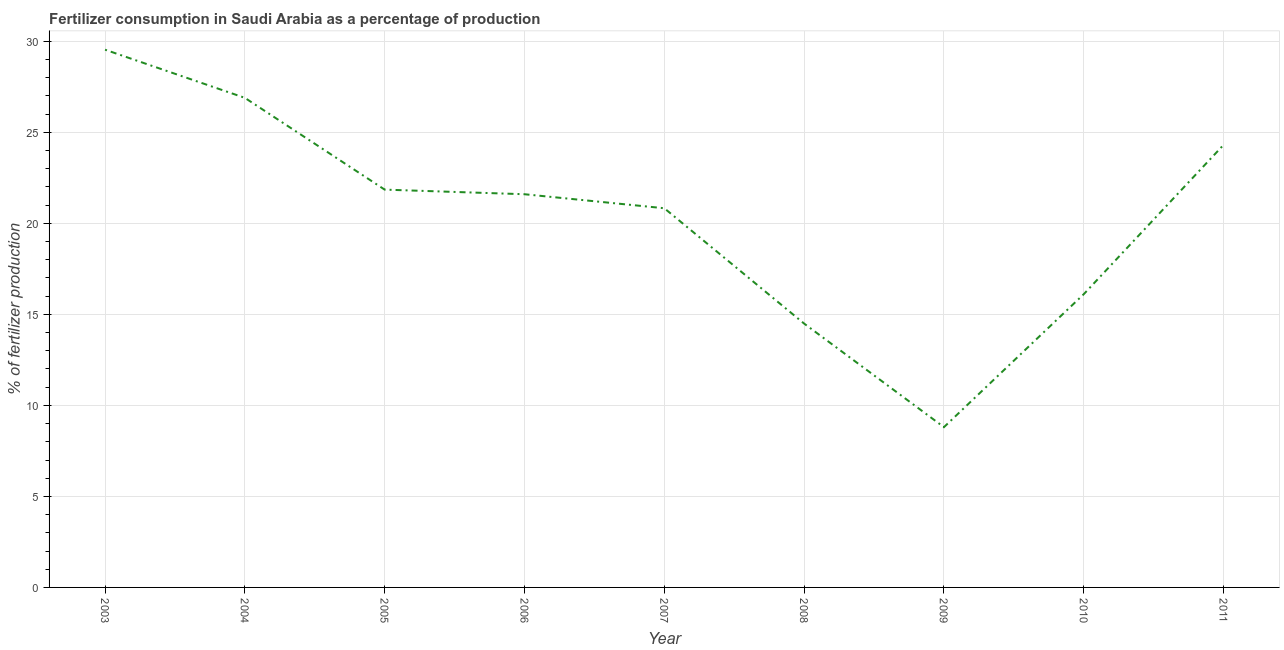What is the amount of fertilizer consumption in 2005?
Make the answer very short. 21.85. Across all years, what is the maximum amount of fertilizer consumption?
Your answer should be compact. 29.54. Across all years, what is the minimum amount of fertilizer consumption?
Make the answer very short. 8.81. In which year was the amount of fertilizer consumption maximum?
Your answer should be very brief. 2003. What is the sum of the amount of fertilizer consumption?
Your answer should be very brief. 184.44. What is the difference between the amount of fertilizer consumption in 2007 and 2008?
Your response must be concise. 6.34. What is the average amount of fertilizer consumption per year?
Ensure brevity in your answer.  20.49. What is the median amount of fertilizer consumption?
Make the answer very short. 21.6. What is the ratio of the amount of fertilizer consumption in 2009 to that in 2010?
Provide a succinct answer. 0.55. Is the amount of fertilizer consumption in 2004 less than that in 2011?
Offer a terse response. No. What is the difference between the highest and the second highest amount of fertilizer consumption?
Your response must be concise. 2.65. What is the difference between the highest and the lowest amount of fertilizer consumption?
Your answer should be compact. 20.74. In how many years, is the amount of fertilizer consumption greater than the average amount of fertilizer consumption taken over all years?
Give a very brief answer. 6. Does the amount of fertilizer consumption monotonically increase over the years?
Ensure brevity in your answer.  No. How many lines are there?
Make the answer very short. 1. What is the difference between two consecutive major ticks on the Y-axis?
Provide a succinct answer. 5. Does the graph contain any zero values?
Offer a very short reply. No. What is the title of the graph?
Your answer should be compact. Fertilizer consumption in Saudi Arabia as a percentage of production. What is the label or title of the X-axis?
Provide a succinct answer. Year. What is the label or title of the Y-axis?
Provide a short and direct response. % of fertilizer production. What is the % of fertilizer production in 2003?
Offer a terse response. 29.54. What is the % of fertilizer production in 2004?
Your response must be concise. 26.9. What is the % of fertilizer production of 2005?
Offer a terse response. 21.85. What is the % of fertilizer production of 2006?
Provide a succinct answer. 21.6. What is the % of fertilizer production in 2007?
Ensure brevity in your answer.  20.83. What is the % of fertilizer production in 2008?
Ensure brevity in your answer.  14.49. What is the % of fertilizer production of 2009?
Your answer should be compact. 8.81. What is the % of fertilizer production in 2010?
Your answer should be compact. 16.11. What is the % of fertilizer production in 2011?
Your answer should be compact. 24.31. What is the difference between the % of fertilizer production in 2003 and 2004?
Provide a succinct answer. 2.65. What is the difference between the % of fertilizer production in 2003 and 2005?
Offer a terse response. 7.69. What is the difference between the % of fertilizer production in 2003 and 2006?
Ensure brevity in your answer.  7.94. What is the difference between the % of fertilizer production in 2003 and 2007?
Your answer should be compact. 8.71. What is the difference between the % of fertilizer production in 2003 and 2008?
Provide a succinct answer. 15.05. What is the difference between the % of fertilizer production in 2003 and 2009?
Offer a very short reply. 20.74. What is the difference between the % of fertilizer production in 2003 and 2010?
Keep it short and to the point. 13.43. What is the difference between the % of fertilizer production in 2003 and 2011?
Your response must be concise. 5.23. What is the difference between the % of fertilizer production in 2004 and 2005?
Your response must be concise. 5.04. What is the difference between the % of fertilizer production in 2004 and 2006?
Provide a short and direct response. 5.29. What is the difference between the % of fertilizer production in 2004 and 2007?
Offer a terse response. 6.06. What is the difference between the % of fertilizer production in 2004 and 2008?
Your answer should be very brief. 12.4. What is the difference between the % of fertilizer production in 2004 and 2009?
Ensure brevity in your answer.  18.09. What is the difference between the % of fertilizer production in 2004 and 2010?
Offer a terse response. 10.79. What is the difference between the % of fertilizer production in 2004 and 2011?
Offer a very short reply. 2.58. What is the difference between the % of fertilizer production in 2005 and 2006?
Provide a succinct answer. 0.25. What is the difference between the % of fertilizer production in 2005 and 2007?
Your answer should be very brief. 1.02. What is the difference between the % of fertilizer production in 2005 and 2008?
Make the answer very short. 7.36. What is the difference between the % of fertilizer production in 2005 and 2009?
Your answer should be very brief. 13.05. What is the difference between the % of fertilizer production in 2005 and 2010?
Ensure brevity in your answer.  5.74. What is the difference between the % of fertilizer production in 2005 and 2011?
Provide a short and direct response. -2.46. What is the difference between the % of fertilizer production in 2006 and 2007?
Your answer should be very brief. 0.77. What is the difference between the % of fertilizer production in 2006 and 2008?
Provide a succinct answer. 7.11. What is the difference between the % of fertilizer production in 2006 and 2009?
Ensure brevity in your answer.  12.8. What is the difference between the % of fertilizer production in 2006 and 2010?
Your response must be concise. 5.49. What is the difference between the % of fertilizer production in 2006 and 2011?
Offer a very short reply. -2.71. What is the difference between the % of fertilizer production in 2007 and 2008?
Give a very brief answer. 6.34. What is the difference between the % of fertilizer production in 2007 and 2009?
Offer a very short reply. 12.03. What is the difference between the % of fertilizer production in 2007 and 2010?
Ensure brevity in your answer.  4.72. What is the difference between the % of fertilizer production in 2007 and 2011?
Your answer should be very brief. -3.48. What is the difference between the % of fertilizer production in 2008 and 2009?
Give a very brief answer. 5.69. What is the difference between the % of fertilizer production in 2008 and 2010?
Make the answer very short. -1.62. What is the difference between the % of fertilizer production in 2008 and 2011?
Keep it short and to the point. -9.82. What is the difference between the % of fertilizer production in 2009 and 2010?
Offer a terse response. -7.3. What is the difference between the % of fertilizer production in 2009 and 2011?
Make the answer very short. -15.51. What is the difference between the % of fertilizer production in 2010 and 2011?
Your answer should be very brief. -8.2. What is the ratio of the % of fertilizer production in 2003 to that in 2004?
Keep it short and to the point. 1.1. What is the ratio of the % of fertilizer production in 2003 to that in 2005?
Provide a succinct answer. 1.35. What is the ratio of the % of fertilizer production in 2003 to that in 2006?
Make the answer very short. 1.37. What is the ratio of the % of fertilizer production in 2003 to that in 2007?
Provide a succinct answer. 1.42. What is the ratio of the % of fertilizer production in 2003 to that in 2008?
Your response must be concise. 2.04. What is the ratio of the % of fertilizer production in 2003 to that in 2009?
Offer a very short reply. 3.35. What is the ratio of the % of fertilizer production in 2003 to that in 2010?
Your answer should be compact. 1.83. What is the ratio of the % of fertilizer production in 2003 to that in 2011?
Make the answer very short. 1.22. What is the ratio of the % of fertilizer production in 2004 to that in 2005?
Your response must be concise. 1.23. What is the ratio of the % of fertilizer production in 2004 to that in 2006?
Ensure brevity in your answer.  1.25. What is the ratio of the % of fertilizer production in 2004 to that in 2007?
Give a very brief answer. 1.29. What is the ratio of the % of fertilizer production in 2004 to that in 2008?
Provide a succinct answer. 1.86. What is the ratio of the % of fertilizer production in 2004 to that in 2009?
Offer a terse response. 3.06. What is the ratio of the % of fertilizer production in 2004 to that in 2010?
Your response must be concise. 1.67. What is the ratio of the % of fertilizer production in 2004 to that in 2011?
Offer a very short reply. 1.11. What is the ratio of the % of fertilizer production in 2005 to that in 2006?
Give a very brief answer. 1.01. What is the ratio of the % of fertilizer production in 2005 to that in 2007?
Give a very brief answer. 1.05. What is the ratio of the % of fertilizer production in 2005 to that in 2008?
Provide a short and direct response. 1.51. What is the ratio of the % of fertilizer production in 2005 to that in 2009?
Offer a terse response. 2.48. What is the ratio of the % of fertilizer production in 2005 to that in 2010?
Provide a short and direct response. 1.36. What is the ratio of the % of fertilizer production in 2005 to that in 2011?
Offer a terse response. 0.9. What is the ratio of the % of fertilizer production in 2006 to that in 2007?
Give a very brief answer. 1.04. What is the ratio of the % of fertilizer production in 2006 to that in 2008?
Offer a very short reply. 1.49. What is the ratio of the % of fertilizer production in 2006 to that in 2009?
Make the answer very short. 2.45. What is the ratio of the % of fertilizer production in 2006 to that in 2010?
Ensure brevity in your answer.  1.34. What is the ratio of the % of fertilizer production in 2006 to that in 2011?
Offer a terse response. 0.89. What is the ratio of the % of fertilizer production in 2007 to that in 2008?
Your answer should be very brief. 1.44. What is the ratio of the % of fertilizer production in 2007 to that in 2009?
Your answer should be very brief. 2.37. What is the ratio of the % of fertilizer production in 2007 to that in 2010?
Your response must be concise. 1.29. What is the ratio of the % of fertilizer production in 2007 to that in 2011?
Keep it short and to the point. 0.86. What is the ratio of the % of fertilizer production in 2008 to that in 2009?
Offer a very short reply. 1.65. What is the ratio of the % of fertilizer production in 2008 to that in 2011?
Offer a very short reply. 0.6. What is the ratio of the % of fertilizer production in 2009 to that in 2010?
Ensure brevity in your answer.  0.55. What is the ratio of the % of fertilizer production in 2009 to that in 2011?
Ensure brevity in your answer.  0.36. What is the ratio of the % of fertilizer production in 2010 to that in 2011?
Provide a short and direct response. 0.66. 